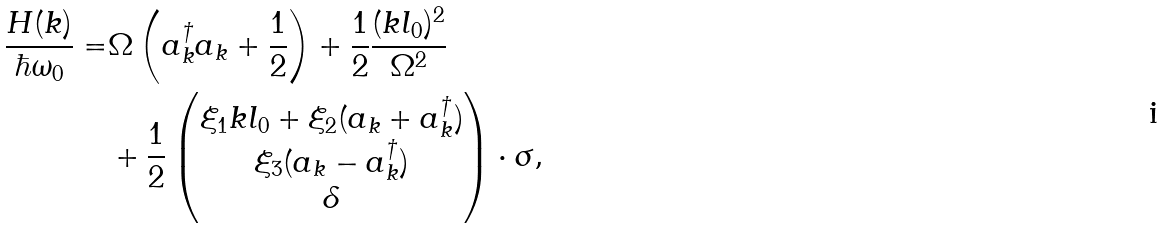Convert formula to latex. <formula><loc_0><loc_0><loc_500><loc_500>\frac { H ( k ) } { \hbar { \omega } _ { 0 } } = & \Omega \left ( a _ { k } ^ { \dagger } a _ { k } + \frac { 1 } { 2 } \right ) + \frac { 1 } { 2 } \frac { ( k l _ { 0 } ) ^ { 2 } } { \Omega ^ { 2 } } \\ & + \frac { 1 } { 2 } \begin{pmatrix} \xi _ { 1 } k l _ { 0 } + \xi _ { 2 } ( a _ { k } + a _ { k } ^ { \dagger } ) \\ \xi _ { 3 } ( a _ { k } - a _ { k } ^ { \dagger } ) \\ \delta \end{pmatrix} \cdot \sigma ,</formula> 